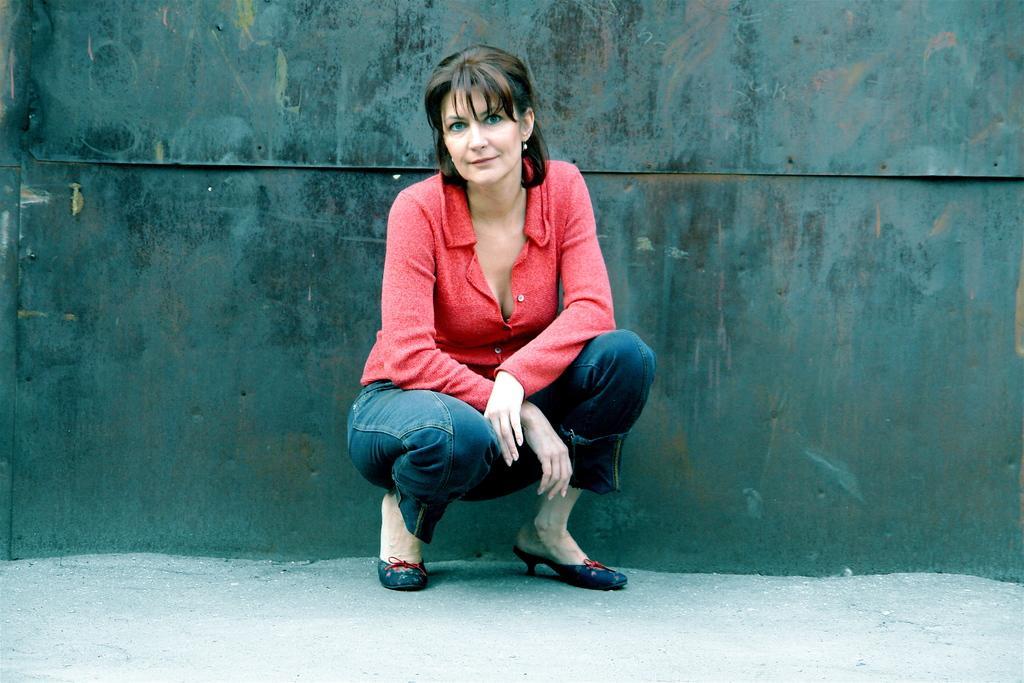In one or two sentences, can you explain what this image depicts? In the center of the image a lady is sitting on her knees and wearing jeans, shirt, shoes. In the background of the image we can see a metal wall. At the bottom of the image we can see the floor. 